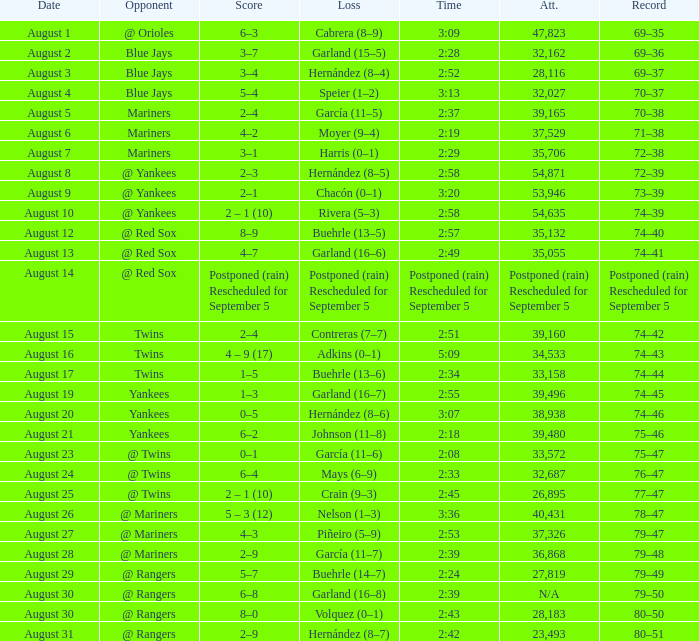Who lost on August 27? Piñeiro (5–9). 